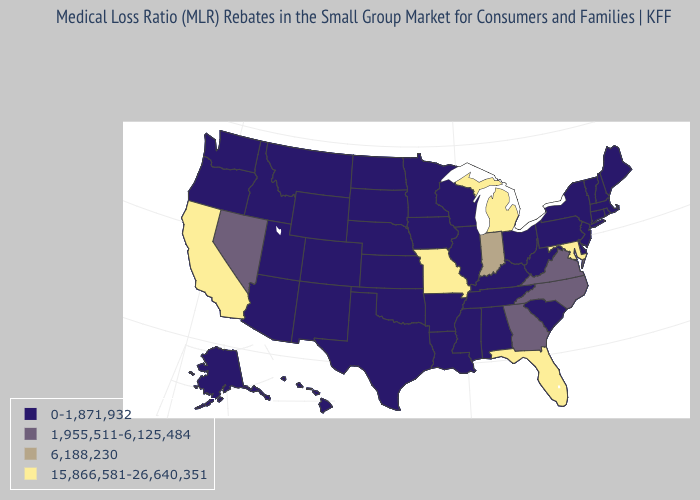What is the value of Vermont?
Be succinct. 0-1,871,932. Does Utah have a higher value than Wyoming?
Answer briefly. No. Does the map have missing data?
Concise answer only. No. How many symbols are there in the legend?
Give a very brief answer. 4. What is the highest value in the USA?
Keep it brief. 15,866,581-26,640,351. Is the legend a continuous bar?
Short answer required. No. What is the value of California?
Give a very brief answer. 15,866,581-26,640,351. Does North Carolina have the lowest value in the USA?
Give a very brief answer. No. Name the states that have a value in the range 1,955,511-6,125,484?
Keep it brief. Georgia, Nevada, North Carolina, Virginia. What is the highest value in the USA?
Write a very short answer. 15,866,581-26,640,351. What is the lowest value in the USA?
Give a very brief answer. 0-1,871,932. Among the states that border Wyoming , which have the highest value?
Quick response, please. Colorado, Idaho, Montana, Nebraska, South Dakota, Utah. What is the lowest value in the MidWest?
Answer briefly. 0-1,871,932. 